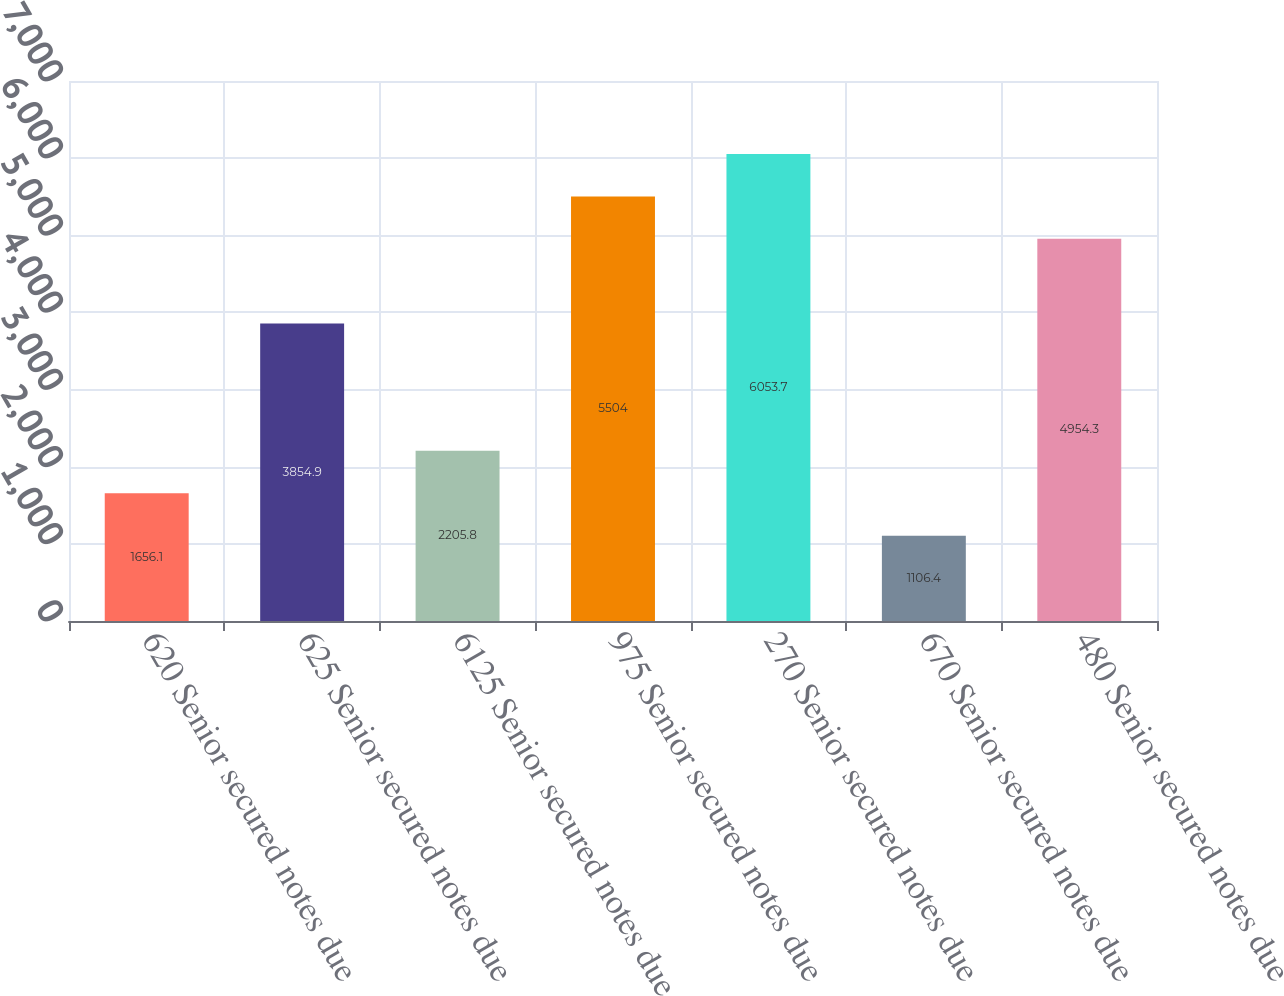<chart> <loc_0><loc_0><loc_500><loc_500><bar_chart><fcel>620 Senior secured notes due<fcel>625 Senior secured notes due<fcel>6125 Senior secured notes due<fcel>975 Senior secured notes due<fcel>270 Senior secured notes due<fcel>670 Senior secured notes due<fcel>480 Senior secured notes due<nl><fcel>1656.1<fcel>3854.9<fcel>2205.8<fcel>5504<fcel>6053.7<fcel>1106.4<fcel>4954.3<nl></chart> 